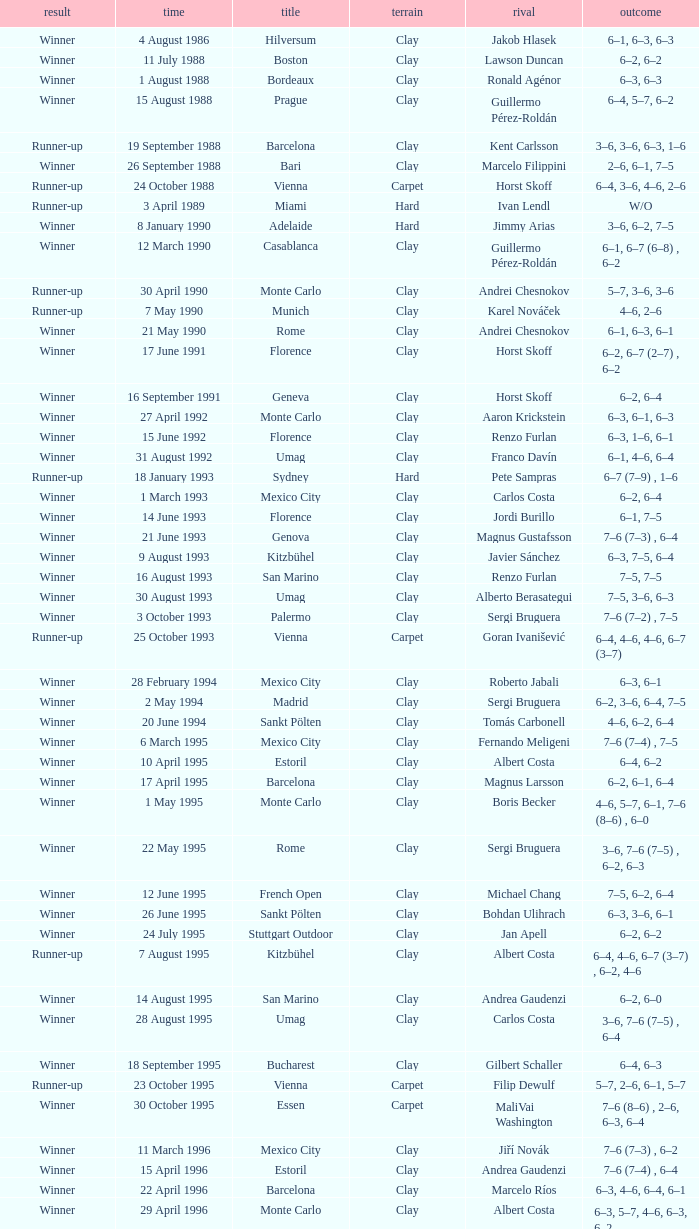Who is the opponent when the surface is clay, the outcome is winner and the championship is estoril on 15 april 1996? Andrea Gaudenzi. 